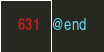Convert code to text. <code><loc_0><loc_0><loc_500><loc_500><_ObjectiveC_>
@end
</code> 